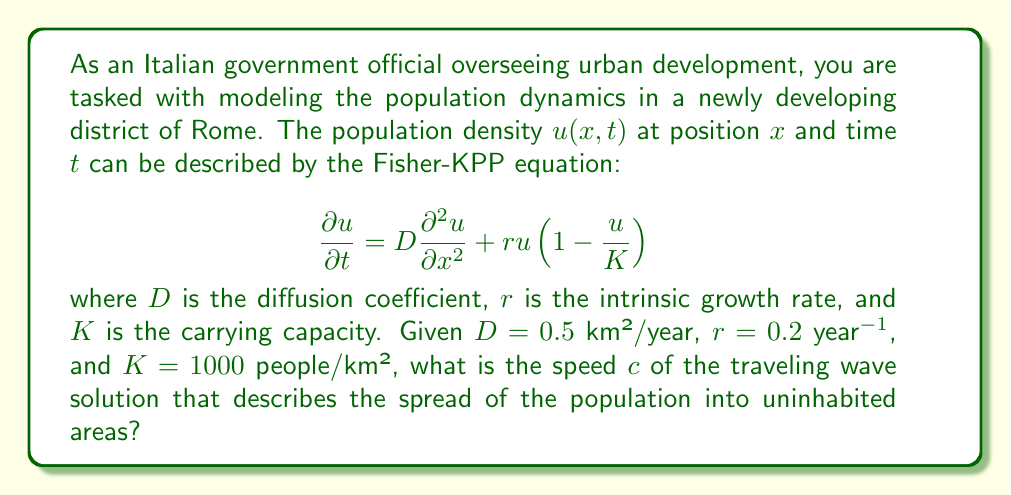Help me with this question. To solve this problem, we need to use the formula for the speed of the traveling wave solution in the Fisher-KPP equation. The steps are as follows:

1) For the Fisher-KPP equation, the speed of the traveling wave solution is given by:

   $$c = 2\sqrt{rD}$$

2) We are given the following values:
   - $D = 0.5$ km²/year (diffusion coefficient)
   - $r = 0.2$ year⁻¹ (intrinsic growth rate)

3) Let's substitute these values into the formula:

   $$c = 2\sqrt{0.2 \cdot 0.5}$$

4) Simplify inside the square root:

   $$c = 2\sqrt{0.1}$$

5) Calculate the square root:

   $$c = 2 \cdot 0.3162277660168379...$$

6) Multiply:

   $$c \approx 0.6324555320336759$$

7) Round to three decimal places:

   $$c \approx 0.632$$ km/year

This result represents the speed at which the population will spread into uninhabited areas, forming a traveling wave of population density.
Answer: The speed of the traveling wave solution is approximately 0.632 km/year. 